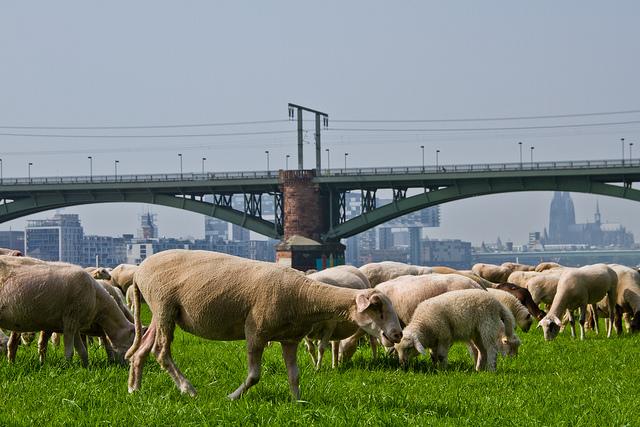Are these birds?
Be succinct. No. How many lampposts line the bridge?
Short answer required. 16. Are there clouds?
Short answer required. No. What are the sheep eating?
Keep it brief. Grass. 